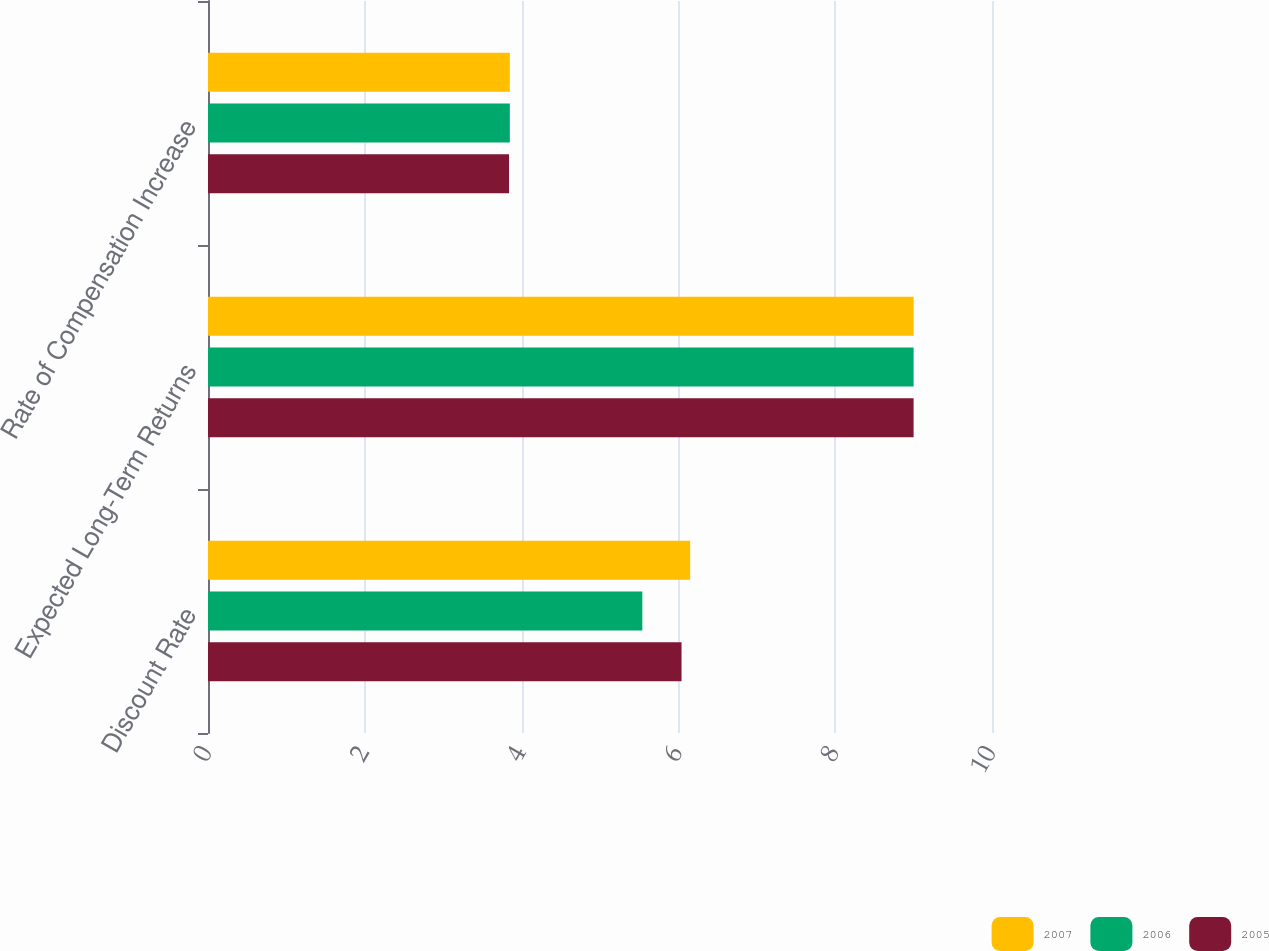<chart> <loc_0><loc_0><loc_500><loc_500><stacked_bar_chart><ecel><fcel>Discount Rate<fcel>Expected Long-Term Returns<fcel>Rate of Compensation Increase<nl><fcel>2007<fcel>6.15<fcel>9<fcel>3.85<nl><fcel>2006<fcel>5.54<fcel>9<fcel>3.85<nl><fcel>2005<fcel>6.04<fcel>9<fcel>3.84<nl></chart> 